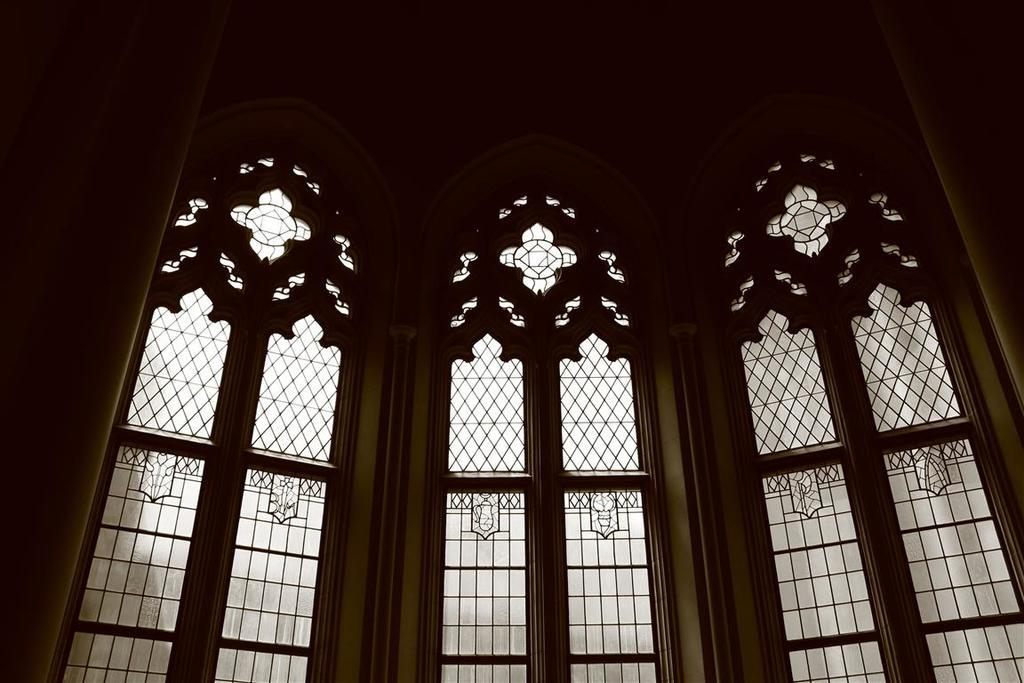What type of view is shown in the image? The image shows an inside view. What architectural feature can be seen in the image? There are designed windows present in the image. Where are the windows located? The windows are on a building. How many toothbrushes can be seen in the image? There are no toothbrushes present in the image. What type of edge is visible on the windows in the image? The provided facts do not mention any specific edge details about the windows, so we cannot answer this question. 